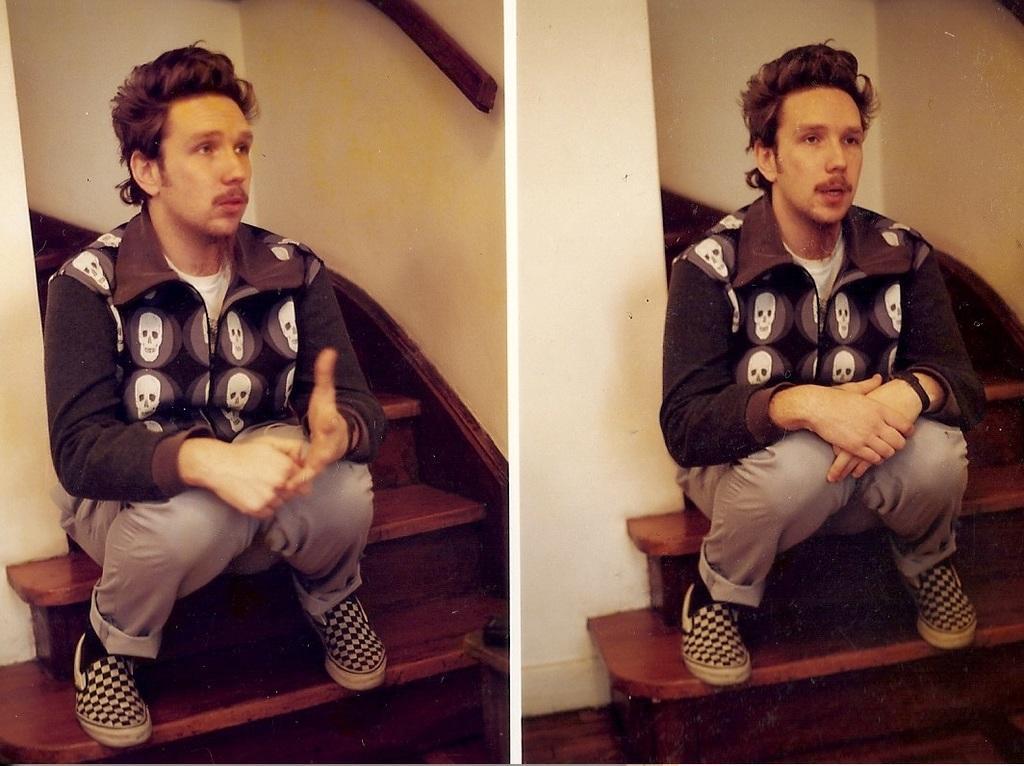Describe this image in one or two sentences. This is a collage image of a person sitting on stairs. 